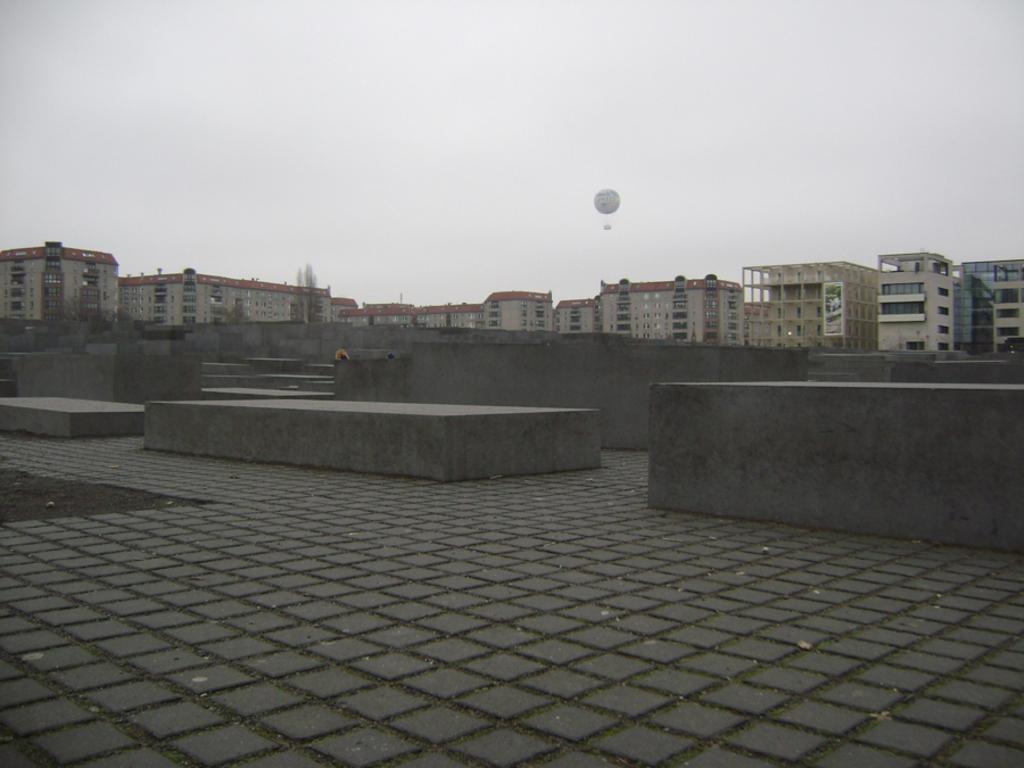What type of structures can be seen in the image? There are buildings in the image. What is the barrier that separates the buildings from the road? There is a fence in the image. What part of the natural environment is visible in the image? The sky is visible in the image. When was the image taken? The image was taken during the day. Where was the image taken? The image was taken on a road. How many mice can be seen climbing the fence in the image? There are no mice present in the image. What type of knot is used to secure the fence in the image? There is no knot visible in the image, as it is a fence rather than a rope or cord. 